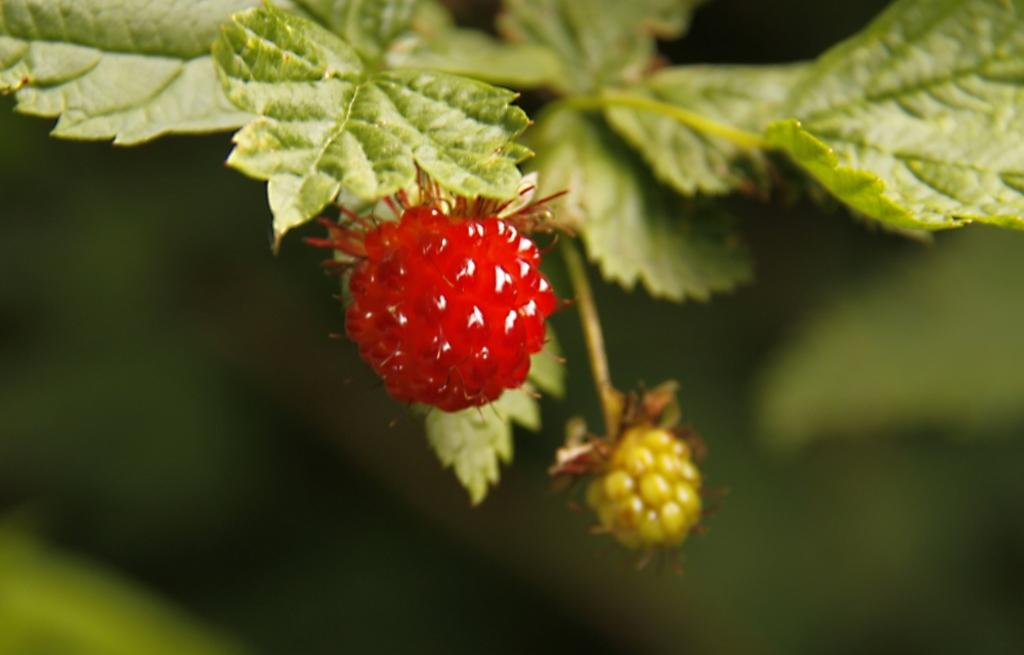What is the main subject of the image? There is a tree in the image. What can be seen on the tree? The tree has berries. What colors are the berries? The berries are in red and green colors. What is the color of the background in the image? The background of the image is green. How is the image blurred? The image is blurred in the background. Can you see a picture of a worm on the tree in the image? There is no picture of a worm on the tree in the image. 